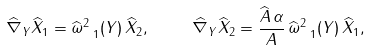Convert formula to latex. <formula><loc_0><loc_0><loc_500><loc_500>\widehat { \nabla } _ { Y } \widehat { X } _ { 1 } = \widehat { \omega } ^ { 2 } _ { \ 1 } ( Y ) \, \widehat { X } _ { 2 } , \quad \ \widehat { \nabla } _ { Y } \widehat { X } _ { 2 } = \frac { \widehat { A } \, \alpha } { A } \, \widehat { \omega } ^ { 2 } _ { \ 1 } ( Y ) \, \widehat { X } _ { 1 } ,</formula> 